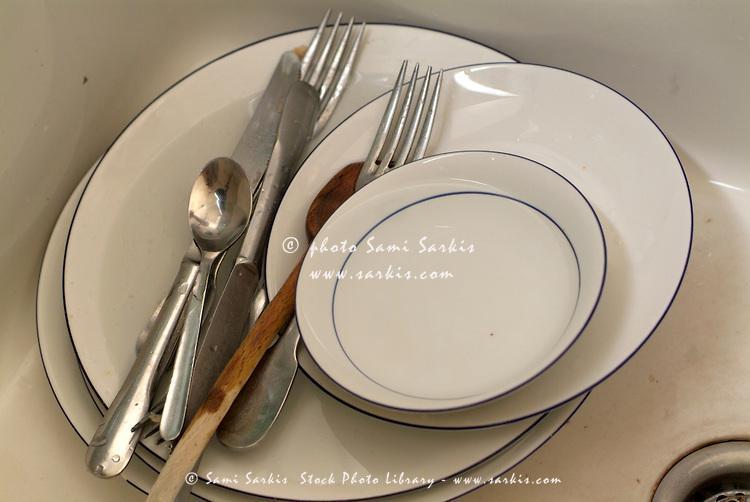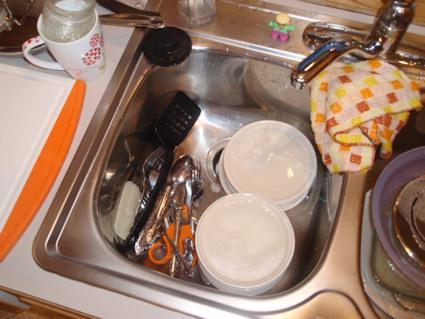The first image is the image on the left, the second image is the image on the right. For the images shown, is this caption "A big upright squarish cutting board is behind a heaping pile of dirty dishes in a sink." true? Answer yes or no. No. The first image is the image on the left, the second image is the image on the right. For the images displayed, is the sentence "At least one window is visible behind a pile of dirty dishes." factually correct? Answer yes or no. No. 